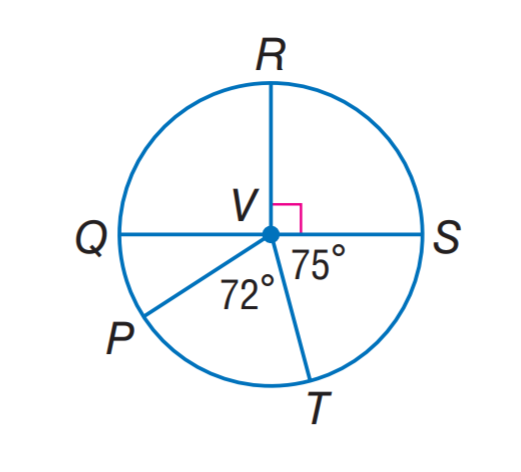Question: Q S is a diameter of \odot V. Find m \widehat P Q R.
Choices:
A. 123
B. 144
C. 147
D. 150
Answer with the letter. Answer: A Question: Q S is a diameter of \odot V. Find m \widehat S T P.
Choices:
A. 123
B. 144
C. 147
D. 150
Answer with the letter. Answer: C Question: Q S is a diameter of \odot V. Find m \widehat Q R T.
Choices:
A. 105
B. 147
C. 255
D. 285
Answer with the letter. Answer: C 